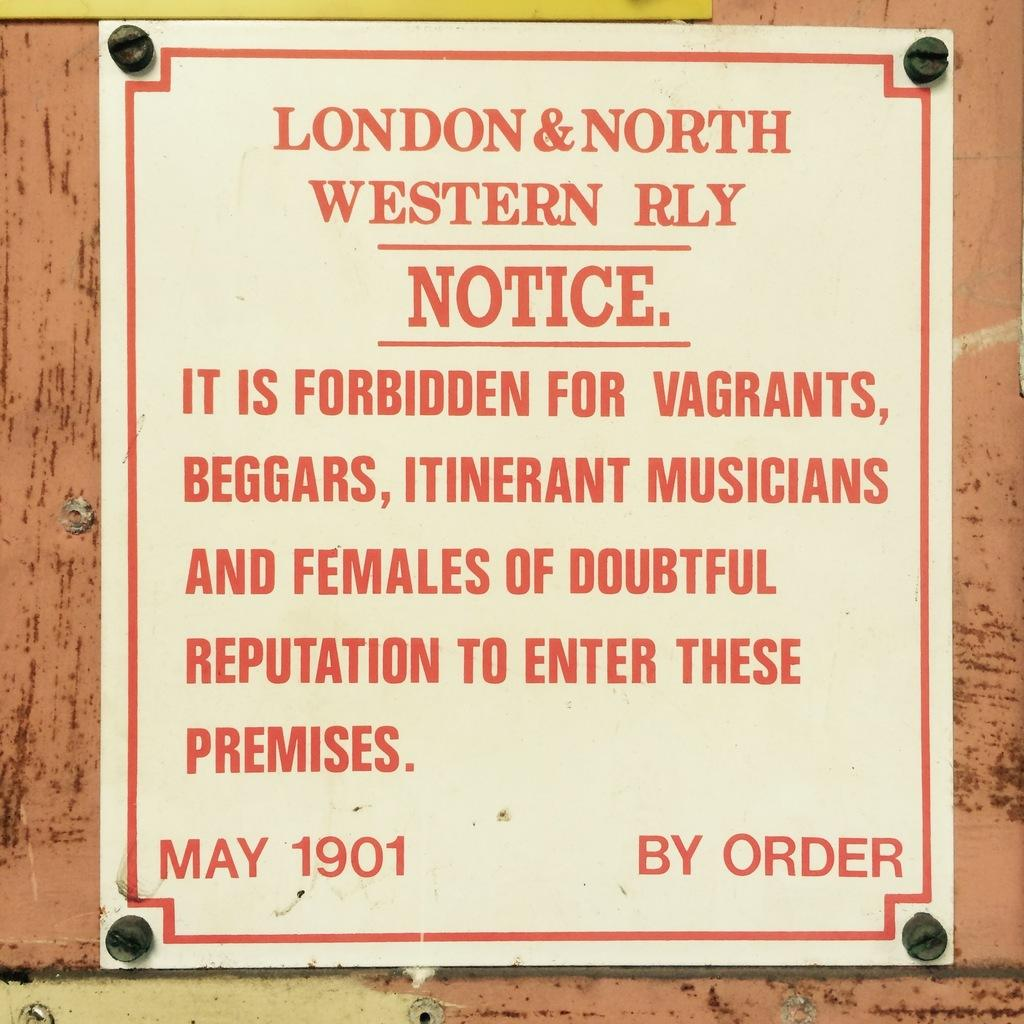<image>
Share a concise interpretation of the image provided. A nailed poster that reads london and nord westen notice on the top. 